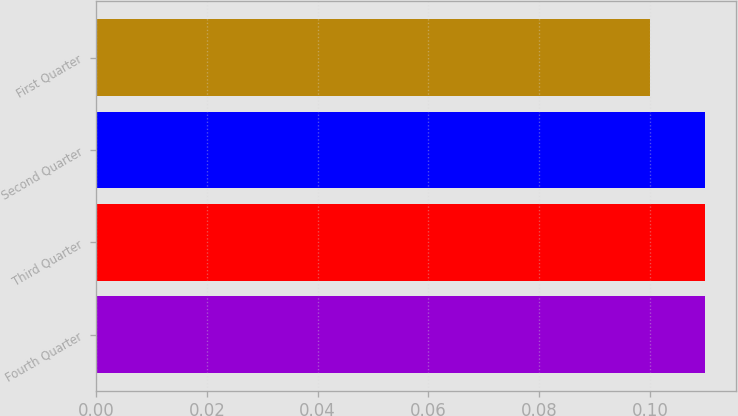Convert chart to OTSL. <chart><loc_0><loc_0><loc_500><loc_500><bar_chart><fcel>Fourth Quarter<fcel>Third Quarter<fcel>Second Quarter<fcel>First Quarter<nl><fcel>0.11<fcel>0.11<fcel>0.11<fcel>0.1<nl></chart> 